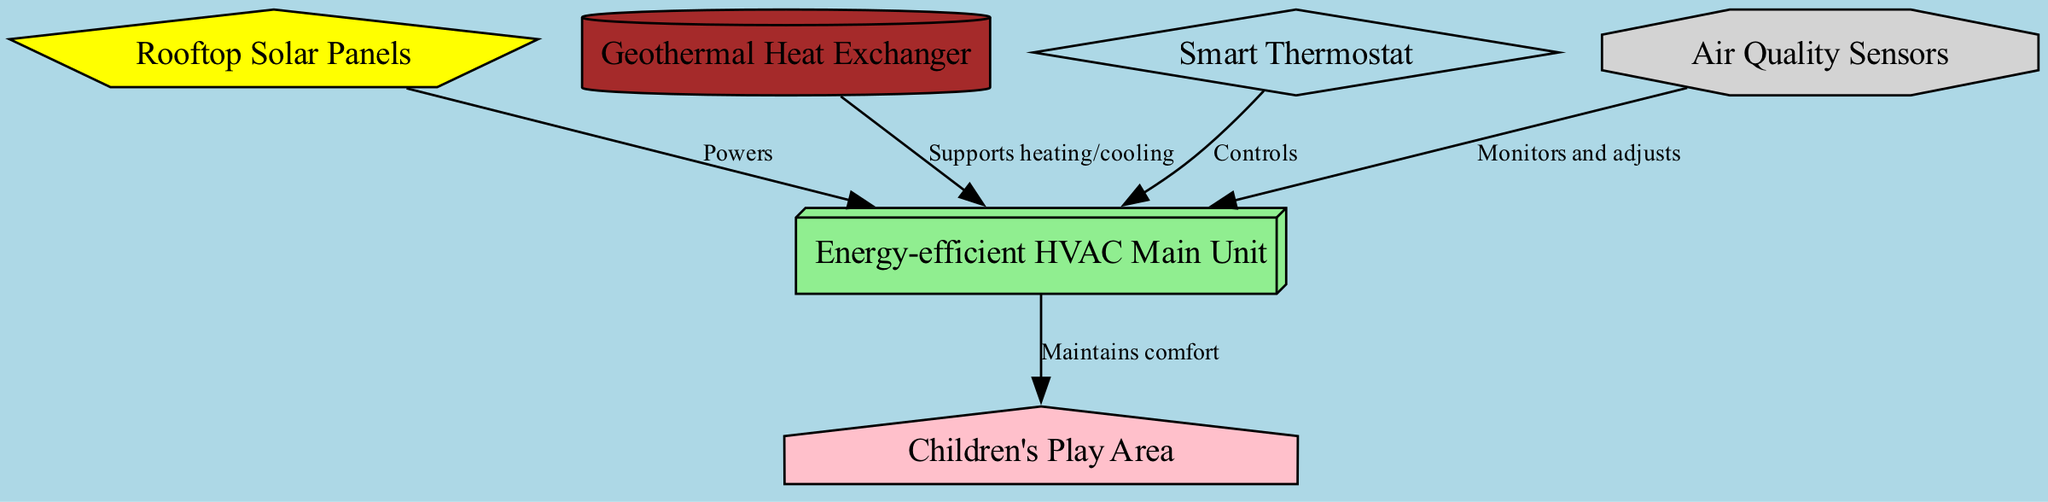What is the main unit of the HVAC system? The main unit is labeled as "Energy-efficient HVAC Main Unit" in the diagram.
Answer: Energy-efficient HVAC Main Unit How many nodes are present in the diagram? There are six nodes in the diagram, as listed: main unit, solar panels, geothermal heat exchanger, smart thermostat, air quality sensors, and play area.
Answer: 6 What connects the solar panels to the main unit? The diagram shows that the solar panels "Powers" the main unit, indicating a direct relationship between them.
Answer: Powers Which component is responsible for controlling the HVAC system? The component responsible for controlling the HVAC system is labeled as "Smart Thermostat" in the diagram.
Answer: Smart Thermostat What component monitors and adjusts the system based on air quality? The component that monitors and adjusts the HVAC system based on air quality is labeled as "Air Quality Sensors" in the diagram.
Answer: Air Quality Sensors Which component is highlighted for heating and cooling support? The component highlighted for supporting heating and cooling is "Geothermal Heat Exchanger," as indicated in the edges connecting to the main unit.
Answer: Geothermal Heat Exchanger How does the main unit affect the children's play area? The main unit "Maintains comfort" in the children's play area, showing the relationship between them in the diagram.
Answer: Maintains comfort What is the shape of the smart thermostat in the diagram? The smart thermostat is represented as a diamond shape according to the custom node styles specified in the diagram.
Answer: Diamond What color represents the air quality sensors in the diagram? The air quality sensors are represented in light grey color, as specified in the node styles of the diagram.
Answer: Light grey 